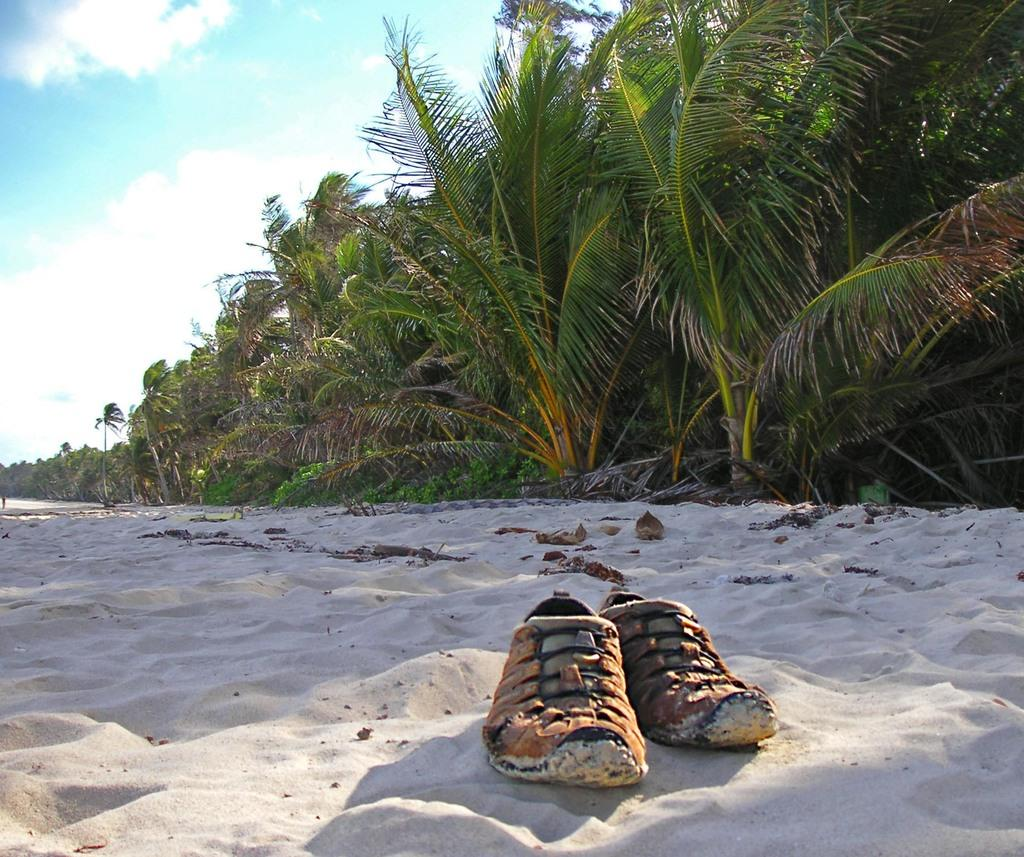What objects are on the sand in the image? There are shoes on the sand in the image. What can be seen in the background of the image? There are trees and the sky visible in the background. What is the condition of the sky in the image? The sky is visible in the background with clouds. How old is the boy in the image? There is no boy present in the image, so it is not possible to determine the age of a boy. 